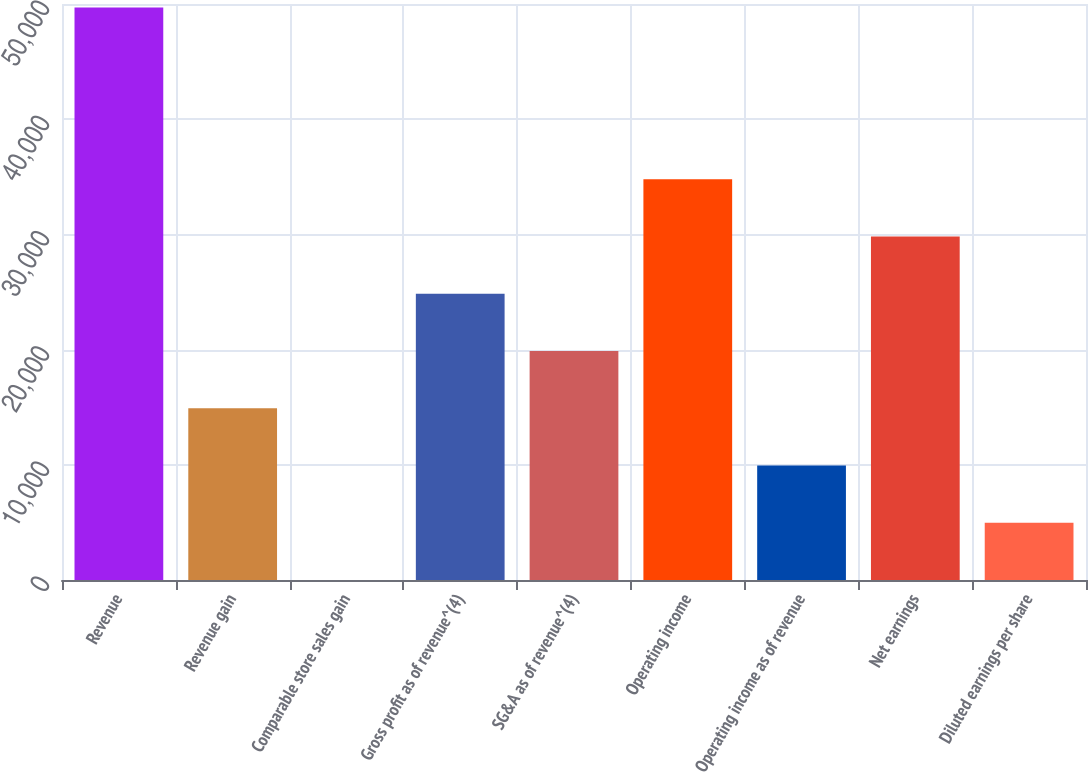<chart> <loc_0><loc_0><loc_500><loc_500><bar_chart><fcel>Revenue<fcel>Revenue gain<fcel>Comparable store sales gain<fcel>Gross profit as of revenue^(4)<fcel>SG&A as of revenue^(4)<fcel>Operating income<fcel>Operating income as of revenue<fcel>Net earnings<fcel>Diluted earnings per share<nl><fcel>49694<fcel>14908.6<fcel>0.6<fcel>24847.3<fcel>19878<fcel>34786<fcel>9939.28<fcel>29816.6<fcel>4969.94<nl></chart> 